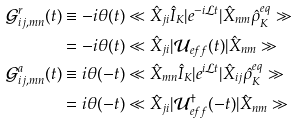<formula> <loc_0><loc_0><loc_500><loc_500>\mathcal { G } ^ { r } _ { i j , m n } ( t ) & \equiv - i \theta ( t ) \ll \hat { X } _ { j i } \hat { I } _ { K } | e ^ { - i \mathcal { L } t } | \hat { X } _ { n m } \hat { \rho } _ { K } ^ { e q } \gg \\ & = - i \theta ( t ) \ll \hat { X } _ { j i } | \mathcal { U } _ { e f f } ( t ) | \hat { X } _ { n m } \gg \\ \mathcal { G } ^ { a } _ { i j , m n } ( t ) & \equiv i \theta ( - t ) \ll \hat { X } _ { m n } \hat { I } _ { K } | e ^ { i \mathcal { L } t } | \hat { X } _ { i j } \hat { \rho } _ { K } ^ { e q } \gg \\ & = i \theta ( - t ) \ll \hat { X } _ { j i } | \mathcal { U } _ { e f f } ^ { \dagger } ( - t ) | \hat { X } _ { n m } \gg</formula> 